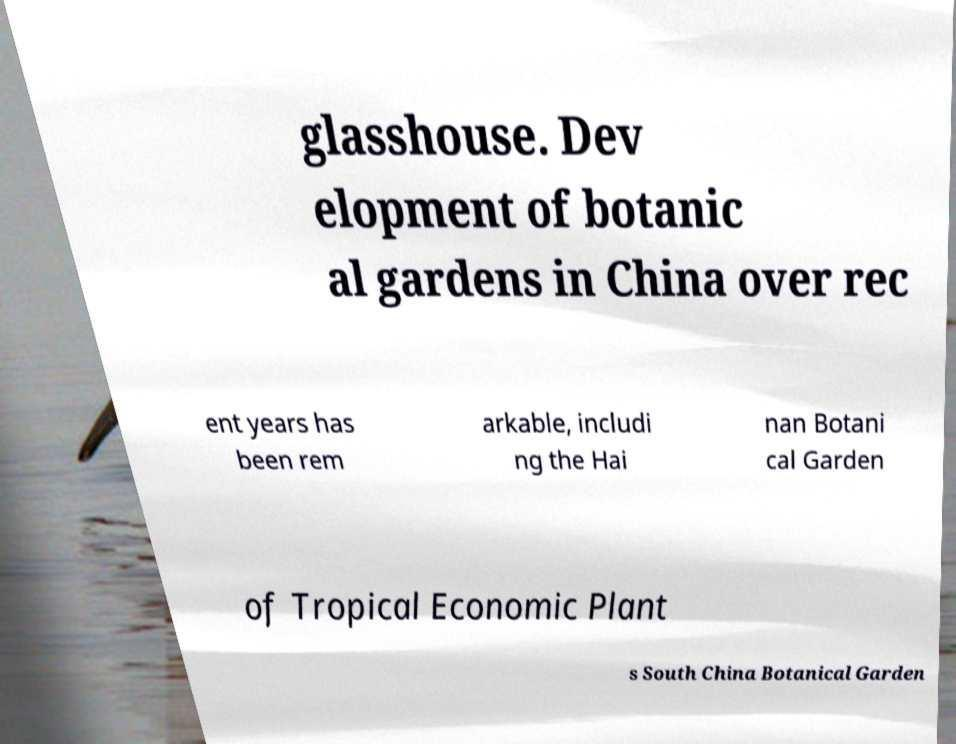What messages or text are displayed in this image? I need them in a readable, typed format. glasshouse. Dev elopment of botanic al gardens in China over rec ent years has been rem arkable, includi ng the Hai nan Botani cal Garden of Tropical Economic Plant s South China Botanical Garden 